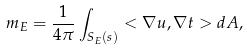<formula> <loc_0><loc_0><loc_500><loc_500>m _ { E } = \frac { 1 } { 4 \pi } \int _ { S _ { E } ( s ) } < \nabla u , \nabla t > d A ,</formula> 